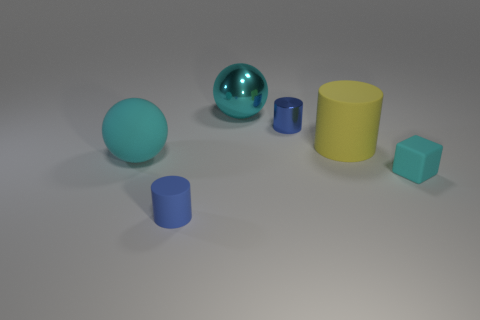How many big cyan spheres are the same material as the tiny cyan thing?
Your answer should be compact. 1. What number of large objects are there?
Your answer should be compact. 3. There is a blue matte object; is it the same size as the cyan sphere behind the big matte cylinder?
Ensure brevity in your answer.  No. There is a small blue object that is on the left side of the blue cylinder behind the tiny cyan rubber cube; what is it made of?
Provide a short and direct response. Rubber. There is a blue object behind the small rubber thing that is behind the small blue thing that is in front of the tiny cube; what size is it?
Ensure brevity in your answer.  Small. There is a yellow matte object; is it the same shape as the blue thing that is behind the small cyan rubber thing?
Ensure brevity in your answer.  Yes. What material is the cyan cube?
Provide a succinct answer. Rubber. How many metallic things are large yellow objects or large gray objects?
Give a very brief answer. 0. Are there fewer big yellow objects behind the small metal cylinder than large cylinders behind the block?
Make the answer very short. Yes. There is a big sphere right of the cylinder that is in front of the large cyan rubber ball; is there a shiny cylinder that is to the left of it?
Your answer should be very brief. No. 